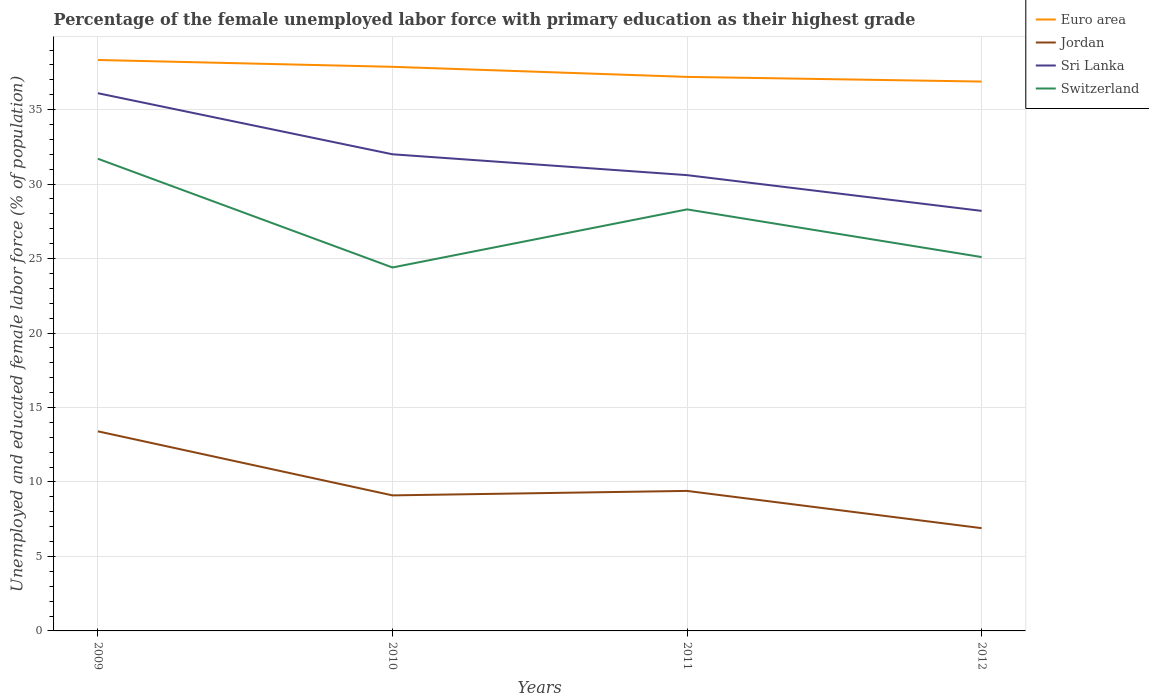How many different coloured lines are there?
Offer a very short reply. 4. Is the number of lines equal to the number of legend labels?
Provide a short and direct response. Yes. Across all years, what is the maximum percentage of the unemployed female labor force with primary education in Jordan?
Ensure brevity in your answer.  6.9. What is the total percentage of the unemployed female labor force with primary education in Jordan in the graph?
Offer a very short reply. 2.2. What is the difference between the highest and the second highest percentage of the unemployed female labor force with primary education in Switzerland?
Provide a succinct answer. 7.3. What is the difference between two consecutive major ticks on the Y-axis?
Provide a short and direct response. 5. Does the graph contain any zero values?
Your answer should be compact. No. How many legend labels are there?
Ensure brevity in your answer.  4. What is the title of the graph?
Keep it short and to the point. Percentage of the female unemployed labor force with primary education as their highest grade. Does "French Polynesia" appear as one of the legend labels in the graph?
Your answer should be very brief. No. What is the label or title of the X-axis?
Your answer should be compact. Years. What is the label or title of the Y-axis?
Keep it short and to the point. Unemployed and educated female labor force (% of population). What is the Unemployed and educated female labor force (% of population) in Euro area in 2009?
Give a very brief answer. 38.33. What is the Unemployed and educated female labor force (% of population) in Jordan in 2009?
Offer a terse response. 13.4. What is the Unemployed and educated female labor force (% of population) in Sri Lanka in 2009?
Make the answer very short. 36.1. What is the Unemployed and educated female labor force (% of population) of Switzerland in 2009?
Give a very brief answer. 31.7. What is the Unemployed and educated female labor force (% of population) of Euro area in 2010?
Keep it short and to the point. 37.87. What is the Unemployed and educated female labor force (% of population) of Jordan in 2010?
Offer a terse response. 9.1. What is the Unemployed and educated female labor force (% of population) in Switzerland in 2010?
Provide a short and direct response. 24.4. What is the Unemployed and educated female labor force (% of population) of Euro area in 2011?
Give a very brief answer. 37.2. What is the Unemployed and educated female labor force (% of population) in Jordan in 2011?
Offer a very short reply. 9.4. What is the Unemployed and educated female labor force (% of population) in Sri Lanka in 2011?
Offer a very short reply. 30.6. What is the Unemployed and educated female labor force (% of population) in Switzerland in 2011?
Provide a short and direct response. 28.3. What is the Unemployed and educated female labor force (% of population) of Euro area in 2012?
Keep it short and to the point. 36.88. What is the Unemployed and educated female labor force (% of population) of Jordan in 2012?
Keep it short and to the point. 6.9. What is the Unemployed and educated female labor force (% of population) of Sri Lanka in 2012?
Offer a very short reply. 28.2. What is the Unemployed and educated female labor force (% of population) of Switzerland in 2012?
Ensure brevity in your answer.  25.1. Across all years, what is the maximum Unemployed and educated female labor force (% of population) in Euro area?
Provide a short and direct response. 38.33. Across all years, what is the maximum Unemployed and educated female labor force (% of population) in Jordan?
Ensure brevity in your answer.  13.4. Across all years, what is the maximum Unemployed and educated female labor force (% of population) of Sri Lanka?
Offer a very short reply. 36.1. Across all years, what is the maximum Unemployed and educated female labor force (% of population) of Switzerland?
Provide a short and direct response. 31.7. Across all years, what is the minimum Unemployed and educated female labor force (% of population) of Euro area?
Provide a short and direct response. 36.88. Across all years, what is the minimum Unemployed and educated female labor force (% of population) in Jordan?
Provide a short and direct response. 6.9. Across all years, what is the minimum Unemployed and educated female labor force (% of population) in Sri Lanka?
Your answer should be compact. 28.2. Across all years, what is the minimum Unemployed and educated female labor force (% of population) in Switzerland?
Provide a short and direct response. 24.4. What is the total Unemployed and educated female labor force (% of population) of Euro area in the graph?
Keep it short and to the point. 150.28. What is the total Unemployed and educated female labor force (% of population) in Jordan in the graph?
Provide a succinct answer. 38.8. What is the total Unemployed and educated female labor force (% of population) of Sri Lanka in the graph?
Provide a short and direct response. 126.9. What is the total Unemployed and educated female labor force (% of population) in Switzerland in the graph?
Offer a terse response. 109.5. What is the difference between the Unemployed and educated female labor force (% of population) in Euro area in 2009 and that in 2010?
Your response must be concise. 0.46. What is the difference between the Unemployed and educated female labor force (% of population) in Jordan in 2009 and that in 2010?
Provide a short and direct response. 4.3. What is the difference between the Unemployed and educated female labor force (% of population) in Sri Lanka in 2009 and that in 2010?
Make the answer very short. 4.1. What is the difference between the Unemployed and educated female labor force (% of population) of Switzerland in 2009 and that in 2010?
Ensure brevity in your answer.  7.3. What is the difference between the Unemployed and educated female labor force (% of population) of Euro area in 2009 and that in 2011?
Your response must be concise. 1.13. What is the difference between the Unemployed and educated female labor force (% of population) in Jordan in 2009 and that in 2011?
Provide a succinct answer. 4. What is the difference between the Unemployed and educated female labor force (% of population) in Sri Lanka in 2009 and that in 2011?
Your answer should be very brief. 5.5. What is the difference between the Unemployed and educated female labor force (% of population) in Switzerland in 2009 and that in 2011?
Your answer should be compact. 3.4. What is the difference between the Unemployed and educated female labor force (% of population) in Euro area in 2009 and that in 2012?
Keep it short and to the point. 1.45. What is the difference between the Unemployed and educated female labor force (% of population) of Jordan in 2009 and that in 2012?
Provide a short and direct response. 6.5. What is the difference between the Unemployed and educated female labor force (% of population) in Euro area in 2010 and that in 2011?
Your answer should be compact. 0.68. What is the difference between the Unemployed and educated female labor force (% of population) of Jordan in 2010 and that in 2012?
Give a very brief answer. 2.2. What is the difference between the Unemployed and educated female labor force (% of population) of Sri Lanka in 2010 and that in 2012?
Your response must be concise. 3.8. What is the difference between the Unemployed and educated female labor force (% of population) in Euro area in 2011 and that in 2012?
Your answer should be compact. 0.31. What is the difference between the Unemployed and educated female labor force (% of population) of Sri Lanka in 2011 and that in 2012?
Give a very brief answer. 2.4. What is the difference between the Unemployed and educated female labor force (% of population) in Switzerland in 2011 and that in 2012?
Offer a terse response. 3.2. What is the difference between the Unemployed and educated female labor force (% of population) of Euro area in 2009 and the Unemployed and educated female labor force (% of population) of Jordan in 2010?
Your answer should be compact. 29.23. What is the difference between the Unemployed and educated female labor force (% of population) in Euro area in 2009 and the Unemployed and educated female labor force (% of population) in Sri Lanka in 2010?
Offer a terse response. 6.33. What is the difference between the Unemployed and educated female labor force (% of population) of Euro area in 2009 and the Unemployed and educated female labor force (% of population) of Switzerland in 2010?
Give a very brief answer. 13.93. What is the difference between the Unemployed and educated female labor force (% of population) in Jordan in 2009 and the Unemployed and educated female labor force (% of population) in Sri Lanka in 2010?
Make the answer very short. -18.6. What is the difference between the Unemployed and educated female labor force (% of population) in Euro area in 2009 and the Unemployed and educated female labor force (% of population) in Jordan in 2011?
Give a very brief answer. 28.93. What is the difference between the Unemployed and educated female labor force (% of population) in Euro area in 2009 and the Unemployed and educated female labor force (% of population) in Sri Lanka in 2011?
Keep it short and to the point. 7.73. What is the difference between the Unemployed and educated female labor force (% of population) in Euro area in 2009 and the Unemployed and educated female labor force (% of population) in Switzerland in 2011?
Keep it short and to the point. 10.03. What is the difference between the Unemployed and educated female labor force (% of population) of Jordan in 2009 and the Unemployed and educated female labor force (% of population) of Sri Lanka in 2011?
Your response must be concise. -17.2. What is the difference between the Unemployed and educated female labor force (% of population) in Jordan in 2009 and the Unemployed and educated female labor force (% of population) in Switzerland in 2011?
Your answer should be compact. -14.9. What is the difference between the Unemployed and educated female labor force (% of population) in Euro area in 2009 and the Unemployed and educated female labor force (% of population) in Jordan in 2012?
Give a very brief answer. 31.43. What is the difference between the Unemployed and educated female labor force (% of population) in Euro area in 2009 and the Unemployed and educated female labor force (% of population) in Sri Lanka in 2012?
Your response must be concise. 10.13. What is the difference between the Unemployed and educated female labor force (% of population) in Euro area in 2009 and the Unemployed and educated female labor force (% of population) in Switzerland in 2012?
Provide a succinct answer. 13.23. What is the difference between the Unemployed and educated female labor force (% of population) in Jordan in 2009 and the Unemployed and educated female labor force (% of population) in Sri Lanka in 2012?
Provide a succinct answer. -14.8. What is the difference between the Unemployed and educated female labor force (% of population) of Euro area in 2010 and the Unemployed and educated female labor force (% of population) of Jordan in 2011?
Ensure brevity in your answer.  28.47. What is the difference between the Unemployed and educated female labor force (% of population) of Euro area in 2010 and the Unemployed and educated female labor force (% of population) of Sri Lanka in 2011?
Keep it short and to the point. 7.27. What is the difference between the Unemployed and educated female labor force (% of population) of Euro area in 2010 and the Unemployed and educated female labor force (% of population) of Switzerland in 2011?
Offer a very short reply. 9.57. What is the difference between the Unemployed and educated female labor force (% of population) in Jordan in 2010 and the Unemployed and educated female labor force (% of population) in Sri Lanka in 2011?
Provide a succinct answer. -21.5. What is the difference between the Unemployed and educated female labor force (% of population) in Jordan in 2010 and the Unemployed and educated female labor force (% of population) in Switzerland in 2011?
Ensure brevity in your answer.  -19.2. What is the difference between the Unemployed and educated female labor force (% of population) of Euro area in 2010 and the Unemployed and educated female labor force (% of population) of Jordan in 2012?
Ensure brevity in your answer.  30.97. What is the difference between the Unemployed and educated female labor force (% of population) in Euro area in 2010 and the Unemployed and educated female labor force (% of population) in Sri Lanka in 2012?
Offer a terse response. 9.67. What is the difference between the Unemployed and educated female labor force (% of population) of Euro area in 2010 and the Unemployed and educated female labor force (% of population) of Switzerland in 2012?
Give a very brief answer. 12.77. What is the difference between the Unemployed and educated female labor force (% of population) of Jordan in 2010 and the Unemployed and educated female labor force (% of population) of Sri Lanka in 2012?
Offer a terse response. -19.1. What is the difference between the Unemployed and educated female labor force (% of population) of Sri Lanka in 2010 and the Unemployed and educated female labor force (% of population) of Switzerland in 2012?
Your response must be concise. 6.9. What is the difference between the Unemployed and educated female labor force (% of population) of Euro area in 2011 and the Unemployed and educated female labor force (% of population) of Jordan in 2012?
Offer a very short reply. 30.3. What is the difference between the Unemployed and educated female labor force (% of population) in Euro area in 2011 and the Unemployed and educated female labor force (% of population) in Sri Lanka in 2012?
Give a very brief answer. 9. What is the difference between the Unemployed and educated female labor force (% of population) of Euro area in 2011 and the Unemployed and educated female labor force (% of population) of Switzerland in 2012?
Keep it short and to the point. 12.1. What is the difference between the Unemployed and educated female labor force (% of population) in Jordan in 2011 and the Unemployed and educated female labor force (% of population) in Sri Lanka in 2012?
Provide a succinct answer. -18.8. What is the difference between the Unemployed and educated female labor force (% of population) of Jordan in 2011 and the Unemployed and educated female labor force (% of population) of Switzerland in 2012?
Your answer should be compact. -15.7. What is the difference between the Unemployed and educated female labor force (% of population) in Sri Lanka in 2011 and the Unemployed and educated female labor force (% of population) in Switzerland in 2012?
Provide a succinct answer. 5.5. What is the average Unemployed and educated female labor force (% of population) of Euro area per year?
Ensure brevity in your answer.  37.57. What is the average Unemployed and educated female labor force (% of population) of Sri Lanka per year?
Your answer should be very brief. 31.73. What is the average Unemployed and educated female labor force (% of population) in Switzerland per year?
Offer a terse response. 27.38. In the year 2009, what is the difference between the Unemployed and educated female labor force (% of population) of Euro area and Unemployed and educated female labor force (% of population) of Jordan?
Provide a succinct answer. 24.93. In the year 2009, what is the difference between the Unemployed and educated female labor force (% of population) in Euro area and Unemployed and educated female labor force (% of population) in Sri Lanka?
Offer a terse response. 2.23. In the year 2009, what is the difference between the Unemployed and educated female labor force (% of population) of Euro area and Unemployed and educated female labor force (% of population) of Switzerland?
Your answer should be very brief. 6.63. In the year 2009, what is the difference between the Unemployed and educated female labor force (% of population) of Jordan and Unemployed and educated female labor force (% of population) of Sri Lanka?
Ensure brevity in your answer.  -22.7. In the year 2009, what is the difference between the Unemployed and educated female labor force (% of population) of Jordan and Unemployed and educated female labor force (% of population) of Switzerland?
Your answer should be compact. -18.3. In the year 2009, what is the difference between the Unemployed and educated female labor force (% of population) of Sri Lanka and Unemployed and educated female labor force (% of population) of Switzerland?
Make the answer very short. 4.4. In the year 2010, what is the difference between the Unemployed and educated female labor force (% of population) of Euro area and Unemployed and educated female labor force (% of population) of Jordan?
Offer a terse response. 28.77. In the year 2010, what is the difference between the Unemployed and educated female labor force (% of population) in Euro area and Unemployed and educated female labor force (% of population) in Sri Lanka?
Offer a terse response. 5.87. In the year 2010, what is the difference between the Unemployed and educated female labor force (% of population) in Euro area and Unemployed and educated female labor force (% of population) in Switzerland?
Offer a terse response. 13.47. In the year 2010, what is the difference between the Unemployed and educated female labor force (% of population) of Jordan and Unemployed and educated female labor force (% of population) of Sri Lanka?
Your answer should be very brief. -22.9. In the year 2010, what is the difference between the Unemployed and educated female labor force (% of population) of Jordan and Unemployed and educated female labor force (% of population) of Switzerland?
Your answer should be very brief. -15.3. In the year 2010, what is the difference between the Unemployed and educated female labor force (% of population) in Sri Lanka and Unemployed and educated female labor force (% of population) in Switzerland?
Your response must be concise. 7.6. In the year 2011, what is the difference between the Unemployed and educated female labor force (% of population) of Euro area and Unemployed and educated female labor force (% of population) of Jordan?
Keep it short and to the point. 27.8. In the year 2011, what is the difference between the Unemployed and educated female labor force (% of population) of Euro area and Unemployed and educated female labor force (% of population) of Sri Lanka?
Provide a succinct answer. 6.6. In the year 2011, what is the difference between the Unemployed and educated female labor force (% of population) of Euro area and Unemployed and educated female labor force (% of population) of Switzerland?
Provide a succinct answer. 8.9. In the year 2011, what is the difference between the Unemployed and educated female labor force (% of population) in Jordan and Unemployed and educated female labor force (% of population) in Sri Lanka?
Your response must be concise. -21.2. In the year 2011, what is the difference between the Unemployed and educated female labor force (% of population) of Jordan and Unemployed and educated female labor force (% of population) of Switzerland?
Give a very brief answer. -18.9. In the year 2012, what is the difference between the Unemployed and educated female labor force (% of population) of Euro area and Unemployed and educated female labor force (% of population) of Jordan?
Offer a terse response. 29.98. In the year 2012, what is the difference between the Unemployed and educated female labor force (% of population) of Euro area and Unemployed and educated female labor force (% of population) of Sri Lanka?
Your answer should be compact. 8.68. In the year 2012, what is the difference between the Unemployed and educated female labor force (% of population) of Euro area and Unemployed and educated female labor force (% of population) of Switzerland?
Your response must be concise. 11.78. In the year 2012, what is the difference between the Unemployed and educated female labor force (% of population) in Jordan and Unemployed and educated female labor force (% of population) in Sri Lanka?
Give a very brief answer. -21.3. In the year 2012, what is the difference between the Unemployed and educated female labor force (% of population) of Jordan and Unemployed and educated female labor force (% of population) of Switzerland?
Your answer should be compact. -18.2. What is the ratio of the Unemployed and educated female labor force (% of population) in Euro area in 2009 to that in 2010?
Provide a succinct answer. 1.01. What is the ratio of the Unemployed and educated female labor force (% of population) of Jordan in 2009 to that in 2010?
Your answer should be compact. 1.47. What is the ratio of the Unemployed and educated female labor force (% of population) of Sri Lanka in 2009 to that in 2010?
Your answer should be very brief. 1.13. What is the ratio of the Unemployed and educated female labor force (% of population) in Switzerland in 2009 to that in 2010?
Your answer should be compact. 1.3. What is the ratio of the Unemployed and educated female labor force (% of population) in Euro area in 2009 to that in 2011?
Provide a succinct answer. 1.03. What is the ratio of the Unemployed and educated female labor force (% of population) in Jordan in 2009 to that in 2011?
Give a very brief answer. 1.43. What is the ratio of the Unemployed and educated female labor force (% of population) of Sri Lanka in 2009 to that in 2011?
Offer a terse response. 1.18. What is the ratio of the Unemployed and educated female labor force (% of population) of Switzerland in 2009 to that in 2011?
Provide a short and direct response. 1.12. What is the ratio of the Unemployed and educated female labor force (% of population) of Euro area in 2009 to that in 2012?
Your answer should be compact. 1.04. What is the ratio of the Unemployed and educated female labor force (% of population) of Jordan in 2009 to that in 2012?
Provide a short and direct response. 1.94. What is the ratio of the Unemployed and educated female labor force (% of population) in Sri Lanka in 2009 to that in 2012?
Your response must be concise. 1.28. What is the ratio of the Unemployed and educated female labor force (% of population) of Switzerland in 2009 to that in 2012?
Ensure brevity in your answer.  1.26. What is the ratio of the Unemployed and educated female labor force (% of population) in Euro area in 2010 to that in 2011?
Offer a terse response. 1.02. What is the ratio of the Unemployed and educated female labor force (% of population) of Jordan in 2010 to that in 2011?
Provide a short and direct response. 0.97. What is the ratio of the Unemployed and educated female labor force (% of population) in Sri Lanka in 2010 to that in 2011?
Make the answer very short. 1.05. What is the ratio of the Unemployed and educated female labor force (% of population) of Switzerland in 2010 to that in 2011?
Your response must be concise. 0.86. What is the ratio of the Unemployed and educated female labor force (% of population) of Euro area in 2010 to that in 2012?
Offer a very short reply. 1.03. What is the ratio of the Unemployed and educated female labor force (% of population) in Jordan in 2010 to that in 2012?
Ensure brevity in your answer.  1.32. What is the ratio of the Unemployed and educated female labor force (% of population) in Sri Lanka in 2010 to that in 2012?
Your response must be concise. 1.13. What is the ratio of the Unemployed and educated female labor force (% of population) in Switzerland in 2010 to that in 2012?
Give a very brief answer. 0.97. What is the ratio of the Unemployed and educated female labor force (% of population) in Euro area in 2011 to that in 2012?
Provide a short and direct response. 1.01. What is the ratio of the Unemployed and educated female labor force (% of population) of Jordan in 2011 to that in 2012?
Offer a very short reply. 1.36. What is the ratio of the Unemployed and educated female labor force (% of population) of Sri Lanka in 2011 to that in 2012?
Offer a terse response. 1.09. What is the ratio of the Unemployed and educated female labor force (% of population) of Switzerland in 2011 to that in 2012?
Your answer should be very brief. 1.13. What is the difference between the highest and the second highest Unemployed and educated female labor force (% of population) of Euro area?
Your response must be concise. 0.46. What is the difference between the highest and the second highest Unemployed and educated female labor force (% of population) of Jordan?
Your answer should be very brief. 4. What is the difference between the highest and the second highest Unemployed and educated female labor force (% of population) in Sri Lanka?
Your answer should be very brief. 4.1. What is the difference between the highest and the second highest Unemployed and educated female labor force (% of population) of Switzerland?
Offer a very short reply. 3.4. What is the difference between the highest and the lowest Unemployed and educated female labor force (% of population) in Euro area?
Your response must be concise. 1.45. What is the difference between the highest and the lowest Unemployed and educated female labor force (% of population) of Jordan?
Ensure brevity in your answer.  6.5. What is the difference between the highest and the lowest Unemployed and educated female labor force (% of population) in Sri Lanka?
Offer a very short reply. 7.9. What is the difference between the highest and the lowest Unemployed and educated female labor force (% of population) of Switzerland?
Ensure brevity in your answer.  7.3. 